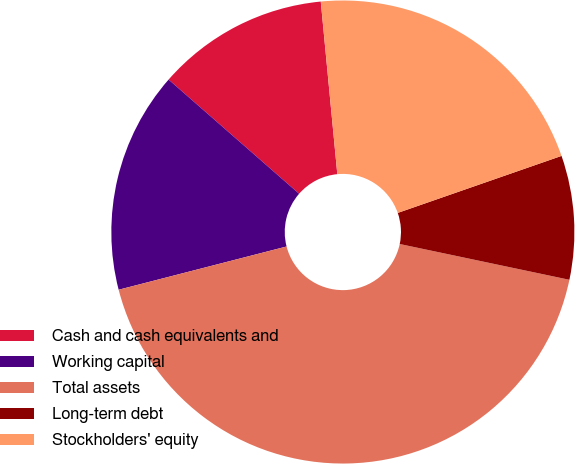Convert chart to OTSL. <chart><loc_0><loc_0><loc_500><loc_500><pie_chart><fcel>Cash and cash equivalents and<fcel>Working capital<fcel>Total assets<fcel>Long-term debt<fcel>Stockholders' equity<nl><fcel>12.04%<fcel>15.45%<fcel>42.68%<fcel>8.64%<fcel>21.19%<nl></chart> 